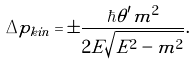Convert formula to latex. <formula><loc_0><loc_0><loc_500><loc_500>\Delta p _ { k i n } = \pm \frac { \hbar { \theta } ^ { \prime } m ^ { 2 } } { 2 E \sqrt { E ^ { 2 } - m ^ { 2 } } } .</formula> 